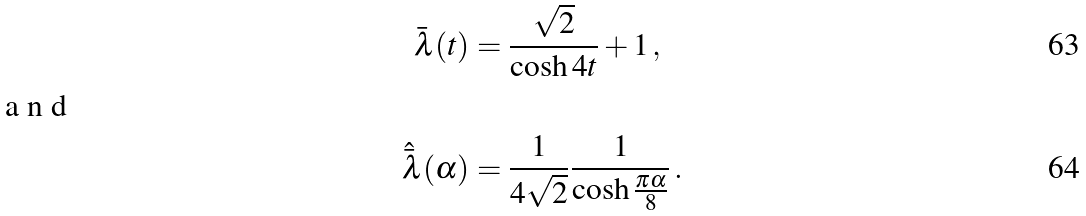<formula> <loc_0><loc_0><loc_500><loc_500>\bar { \lambda } ( t ) & = \frac { \sqrt { 2 } } { \cosh 4 t } + 1 \, , \\ \intertext { a n d } \hat { \bar { \lambda } } ( \alpha ) & = \frac { 1 } { 4 \sqrt { 2 } } \frac { 1 } { \cosh \frac { \pi \alpha } { 8 } } \, .</formula> 